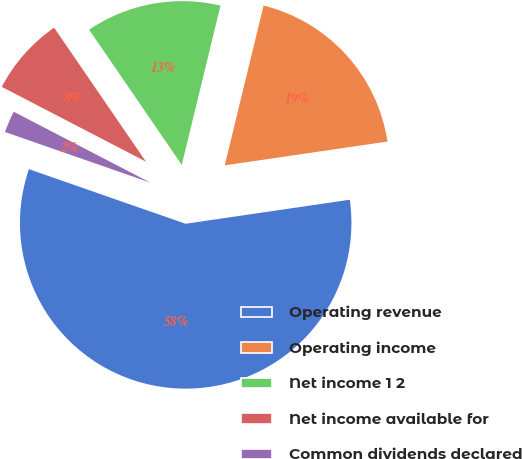Convert chart. <chart><loc_0><loc_0><loc_500><loc_500><pie_chart><fcel>Operating revenue<fcel>Operating income<fcel>Net income 1 2<fcel>Net income available for<fcel>Common dividends declared<nl><fcel>57.65%<fcel>18.89%<fcel>13.36%<fcel>7.82%<fcel>2.28%<nl></chart> 